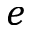<formula> <loc_0><loc_0><loc_500><loc_500>e</formula> 